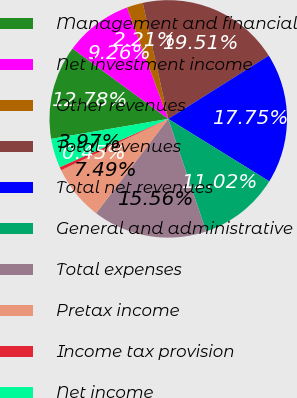Convert chart to OTSL. <chart><loc_0><loc_0><loc_500><loc_500><pie_chart><fcel>Management and financial<fcel>Net investment income<fcel>Other revenues<fcel>Total revenues<fcel>Total net revenues<fcel>General and administrative<fcel>Total expenses<fcel>Pretax income<fcel>Income tax provision<fcel>Net income<nl><fcel>12.78%<fcel>9.26%<fcel>2.21%<fcel>19.51%<fcel>17.75%<fcel>11.02%<fcel>15.56%<fcel>7.49%<fcel>0.45%<fcel>3.97%<nl></chart> 